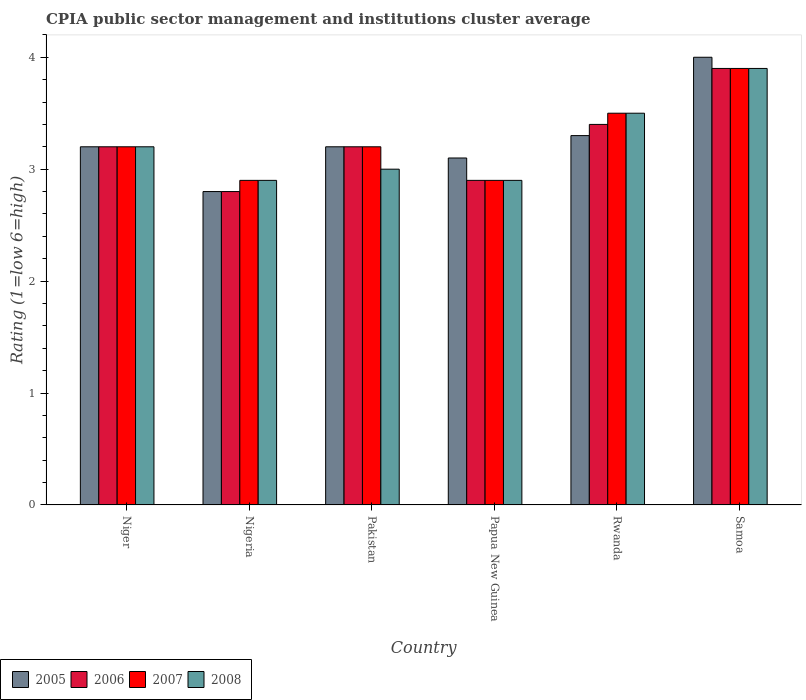How many different coloured bars are there?
Make the answer very short. 4. How many groups of bars are there?
Provide a short and direct response. 6. Are the number of bars per tick equal to the number of legend labels?
Offer a terse response. Yes. Are the number of bars on each tick of the X-axis equal?
Your answer should be very brief. Yes. How many bars are there on the 4th tick from the right?
Your answer should be compact. 4. What is the label of the 4th group of bars from the left?
Offer a terse response. Papua New Guinea. What is the CPIA rating in 2006 in Pakistan?
Make the answer very short. 3.2. In which country was the CPIA rating in 2006 maximum?
Provide a succinct answer. Samoa. In which country was the CPIA rating in 2008 minimum?
Keep it short and to the point. Nigeria. What is the total CPIA rating in 2005 in the graph?
Offer a terse response. 19.6. What is the difference between the CPIA rating in 2007 in Rwanda and the CPIA rating in 2005 in Niger?
Give a very brief answer. 0.3. What is the average CPIA rating in 2007 per country?
Provide a short and direct response. 3.27. What is the difference between the CPIA rating of/in 2006 and CPIA rating of/in 2008 in Rwanda?
Your response must be concise. -0.1. What is the ratio of the CPIA rating in 2007 in Nigeria to that in Samoa?
Make the answer very short. 0.74. Is the CPIA rating in 2006 in Niger less than that in Samoa?
Your answer should be compact. Yes. What is the difference between the highest and the second highest CPIA rating in 2007?
Your response must be concise. -0.4. What is the difference between the highest and the lowest CPIA rating in 2007?
Your answer should be very brief. 1. Is it the case that in every country, the sum of the CPIA rating in 2005 and CPIA rating in 2006 is greater than the sum of CPIA rating in 2008 and CPIA rating in 2007?
Your answer should be very brief. No. How many bars are there?
Ensure brevity in your answer.  24. How many countries are there in the graph?
Make the answer very short. 6. What is the difference between two consecutive major ticks on the Y-axis?
Your answer should be very brief. 1. Does the graph contain grids?
Your answer should be compact. No. Where does the legend appear in the graph?
Keep it short and to the point. Bottom left. What is the title of the graph?
Give a very brief answer. CPIA public sector management and institutions cluster average. Does "1989" appear as one of the legend labels in the graph?
Your response must be concise. No. What is the label or title of the X-axis?
Your answer should be very brief. Country. What is the label or title of the Y-axis?
Provide a short and direct response. Rating (1=low 6=high). What is the Rating (1=low 6=high) of 2005 in Niger?
Your answer should be very brief. 3.2. What is the Rating (1=low 6=high) in 2007 in Niger?
Make the answer very short. 3.2. What is the Rating (1=low 6=high) in 2008 in Niger?
Keep it short and to the point. 3.2. What is the Rating (1=low 6=high) of 2007 in Nigeria?
Your answer should be very brief. 2.9. What is the Rating (1=low 6=high) in 2005 in Pakistan?
Your response must be concise. 3.2. What is the Rating (1=low 6=high) of 2006 in Pakistan?
Make the answer very short. 3.2. What is the Rating (1=low 6=high) in 2007 in Pakistan?
Ensure brevity in your answer.  3.2. What is the Rating (1=low 6=high) of 2008 in Pakistan?
Your answer should be very brief. 3. What is the Rating (1=low 6=high) of 2005 in Papua New Guinea?
Provide a succinct answer. 3.1. What is the Rating (1=low 6=high) of 2006 in Papua New Guinea?
Your response must be concise. 2.9. What is the Rating (1=low 6=high) of 2007 in Papua New Guinea?
Give a very brief answer. 2.9. What is the Rating (1=low 6=high) in 2005 in Rwanda?
Make the answer very short. 3.3. What is the Rating (1=low 6=high) in 2008 in Rwanda?
Your response must be concise. 3.5. Across all countries, what is the maximum Rating (1=low 6=high) of 2006?
Make the answer very short. 3.9. Across all countries, what is the minimum Rating (1=low 6=high) of 2007?
Offer a terse response. 2.9. What is the total Rating (1=low 6=high) in 2005 in the graph?
Your answer should be very brief. 19.6. What is the total Rating (1=low 6=high) in 2007 in the graph?
Make the answer very short. 19.6. What is the total Rating (1=low 6=high) in 2008 in the graph?
Keep it short and to the point. 19.4. What is the difference between the Rating (1=low 6=high) of 2005 in Niger and that in Nigeria?
Provide a succinct answer. 0.4. What is the difference between the Rating (1=low 6=high) of 2007 in Niger and that in Nigeria?
Ensure brevity in your answer.  0.3. What is the difference between the Rating (1=low 6=high) in 2005 in Niger and that in Pakistan?
Provide a succinct answer. 0. What is the difference between the Rating (1=low 6=high) of 2007 in Niger and that in Pakistan?
Give a very brief answer. 0. What is the difference between the Rating (1=low 6=high) in 2006 in Niger and that in Papua New Guinea?
Make the answer very short. 0.3. What is the difference between the Rating (1=low 6=high) in 2007 in Niger and that in Papua New Guinea?
Offer a terse response. 0.3. What is the difference between the Rating (1=low 6=high) of 2008 in Niger and that in Papua New Guinea?
Ensure brevity in your answer.  0.3. What is the difference between the Rating (1=low 6=high) in 2008 in Niger and that in Rwanda?
Keep it short and to the point. -0.3. What is the difference between the Rating (1=low 6=high) of 2005 in Niger and that in Samoa?
Your answer should be compact. -0.8. What is the difference between the Rating (1=low 6=high) of 2008 in Niger and that in Samoa?
Offer a terse response. -0.7. What is the difference between the Rating (1=low 6=high) in 2005 in Nigeria and that in Pakistan?
Your response must be concise. -0.4. What is the difference between the Rating (1=low 6=high) of 2007 in Nigeria and that in Pakistan?
Keep it short and to the point. -0.3. What is the difference between the Rating (1=low 6=high) of 2005 in Nigeria and that in Papua New Guinea?
Ensure brevity in your answer.  -0.3. What is the difference between the Rating (1=low 6=high) in 2007 in Nigeria and that in Papua New Guinea?
Your answer should be compact. 0. What is the difference between the Rating (1=low 6=high) of 2005 in Nigeria and that in Samoa?
Provide a succinct answer. -1.2. What is the difference between the Rating (1=low 6=high) of 2006 in Nigeria and that in Samoa?
Give a very brief answer. -1.1. What is the difference between the Rating (1=low 6=high) in 2006 in Pakistan and that in Papua New Guinea?
Make the answer very short. 0.3. What is the difference between the Rating (1=low 6=high) of 2007 in Pakistan and that in Papua New Guinea?
Your response must be concise. 0.3. What is the difference between the Rating (1=low 6=high) in 2007 in Pakistan and that in Rwanda?
Keep it short and to the point. -0.3. What is the difference between the Rating (1=low 6=high) of 2005 in Pakistan and that in Samoa?
Make the answer very short. -0.8. What is the difference between the Rating (1=low 6=high) in 2006 in Pakistan and that in Samoa?
Provide a short and direct response. -0.7. What is the difference between the Rating (1=low 6=high) of 2007 in Pakistan and that in Samoa?
Provide a succinct answer. -0.7. What is the difference between the Rating (1=low 6=high) in 2008 in Pakistan and that in Samoa?
Provide a short and direct response. -0.9. What is the difference between the Rating (1=low 6=high) of 2005 in Papua New Guinea and that in Rwanda?
Your response must be concise. -0.2. What is the difference between the Rating (1=low 6=high) of 2006 in Papua New Guinea and that in Rwanda?
Your response must be concise. -0.5. What is the difference between the Rating (1=low 6=high) in 2007 in Papua New Guinea and that in Rwanda?
Provide a succinct answer. -0.6. What is the difference between the Rating (1=low 6=high) in 2008 in Papua New Guinea and that in Rwanda?
Keep it short and to the point. -0.6. What is the difference between the Rating (1=low 6=high) of 2005 in Papua New Guinea and that in Samoa?
Offer a very short reply. -0.9. What is the difference between the Rating (1=low 6=high) of 2006 in Papua New Guinea and that in Samoa?
Offer a terse response. -1. What is the difference between the Rating (1=low 6=high) of 2008 in Papua New Guinea and that in Samoa?
Provide a succinct answer. -1. What is the difference between the Rating (1=low 6=high) in 2005 in Rwanda and that in Samoa?
Ensure brevity in your answer.  -0.7. What is the difference between the Rating (1=low 6=high) in 2006 in Rwanda and that in Samoa?
Offer a very short reply. -0.5. What is the difference between the Rating (1=low 6=high) in 2008 in Rwanda and that in Samoa?
Give a very brief answer. -0.4. What is the difference between the Rating (1=low 6=high) in 2005 in Niger and the Rating (1=low 6=high) in 2006 in Nigeria?
Offer a terse response. 0.4. What is the difference between the Rating (1=low 6=high) of 2006 in Niger and the Rating (1=low 6=high) of 2007 in Nigeria?
Ensure brevity in your answer.  0.3. What is the difference between the Rating (1=low 6=high) of 2007 in Niger and the Rating (1=low 6=high) of 2008 in Nigeria?
Offer a terse response. 0.3. What is the difference between the Rating (1=low 6=high) in 2005 in Niger and the Rating (1=low 6=high) in 2007 in Pakistan?
Your answer should be compact. 0. What is the difference between the Rating (1=low 6=high) of 2005 in Niger and the Rating (1=low 6=high) of 2008 in Pakistan?
Offer a very short reply. 0.2. What is the difference between the Rating (1=low 6=high) of 2006 in Niger and the Rating (1=low 6=high) of 2008 in Pakistan?
Ensure brevity in your answer.  0.2. What is the difference between the Rating (1=low 6=high) of 2006 in Niger and the Rating (1=low 6=high) of 2007 in Papua New Guinea?
Your response must be concise. 0.3. What is the difference between the Rating (1=low 6=high) in 2006 in Niger and the Rating (1=low 6=high) in 2008 in Papua New Guinea?
Give a very brief answer. 0.3. What is the difference between the Rating (1=low 6=high) in 2005 in Niger and the Rating (1=low 6=high) in 2007 in Rwanda?
Your answer should be compact. -0.3. What is the difference between the Rating (1=low 6=high) in 2007 in Niger and the Rating (1=low 6=high) in 2008 in Rwanda?
Your response must be concise. -0.3. What is the difference between the Rating (1=low 6=high) of 2005 in Niger and the Rating (1=low 6=high) of 2006 in Samoa?
Offer a very short reply. -0.7. What is the difference between the Rating (1=low 6=high) of 2005 in Niger and the Rating (1=low 6=high) of 2008 in Samoa?
Your answer should be very brief. -0.7. What is the difference between the Rating (1=low 6=high) in 2005 in Nigeria and the Rating (1=low 6=high) in 2008 in Pakistan?
Your answer should be compact. -0.2. What is the difference between the Rating (1=low 6=high) in 2006 in Nigeria and the Rating (1=low 6=high) in 2007 in Pakistan?
Your answer should be very brief. -0.4. What is the difference between the Rating (1=low 6=high) in 2006 in Nigeria and the Rating (1=low 6=high) in 2008 in Pakistan?
Offer a terse response. -0.2. What is the difference between the Rating (1=low 6=high) in 2007 in Nigeria and the Rating (1=low 6=high) in 2008 in Pakistan?
Provide a short and direct response. -0.1. What is the difference between the Rating (1=low 6=high) in 2006 in Nigeria and the Rating (1=low 6=high) in 2007 in Papua New Guinea?
Keep it short and to the point. -0.1. What is the difference between the Rating (1=low 6=high) of 2006 in Nigeria and the Rating (1=low 6=high) of 2008 in Papua New Guinea?
Provide a short and direct response. -0.1. What is the difference between the Rating (1=low 6=high) of 2007 in Nigeria and the Rating (1=low 6=high) of 2008 in Papua New Guinea?
Your response must be concise. 0. What is the difference between the Rating (1=low 6=high) in 2005 in Nigeria and the Rating (1=low 6=high) in 2006 in Rwanda?
Make the answer very short. -0.6. What is the difference between the Rating (1=low 6=high) in 2005 in Nigeria and the Rating (1=low 6=high) in 2007 in Rwanda?
Provide a succinct answer. -0.7. What is the difference between the Rating (1=low 6=high) of 2005 in Nigeria and the Rating (1=low 6=high) of 2008 in Rwanda?
Provide a short and direct response. -0.7. What is the difference between the Rating (1=low 6=high) of 2006 in Nigeria and the Rating (1=low 6=high) of 2008 in Rwanda?
Offer a very short reply. -0.7. What is the difference between the Rating (1=low 6=high) of 2007 in Nigeria and the Rating (1=low 6=high) of 2008 in Rwanda?
Provide a succinct answer. -0.6. What is the difference between the Rating (1=low 6=high) of 2005 in Nigeria and the Rating (1=low 6=high) of 2006 in Samoa?
Provide a short and direct response. -1.1. What is the difference between the Rating (1=low 6=high) of 2007 in Nigeria and the Rating (1=low 6=high) of 2008 in Samoa?
Offer a very short reply. -1. What is the difference between the Rating (1=low 6=high) of 2005 in Pakistan and the Rating (1=low 6=high) of 2007 in Papua New Guinea?
Offer a terse response. 0.3. What is the difference between the Rating (1=low 6=high) in 2005 in Pakistan and the Rating (1=low 6=high) in 2008 in Papua New Guinea?
Make the answer very short. 0.3. What is the difference between the Rating (1=low 6=high) in 2006 in Pakistan and the Rating (1=low 6=high) in 2007 in Papua New Guinea?
Give a very brief answer. 0.3. What is the difference between the Rating (1=low 6=high) in 2006 in Pakistan and the Rating (1=low 6=high) in 2008 in Papua New Guinea?
Keep it short and to the point. 0.3. What is the difference between the Rating (1=low 6=high) in 2007 in Pakistan and the Rating (1=low 6=high) in 2008 in Papua New Guinea?
Provide a short and direct response. 0.3. What is the difference between the Rating (1=low 6=high) of 2005 in Pakistan and the Rating (1=low 6=high) of 2007 in Rwanda?
Your answer should be compact. -0.3. What is the difference between the Rating (1=low 6=high) in 2005 in Pakistan and the Rating (1=low 6=high) in 2008 in Rwanda?
Ensure brevity in your answer.  -0.3. What is the difference between the Rating (1=low 6=high) in 2005 in Pakistan and the Rating (1=low 6=high) in 2007 in Samoa?
Your answer should be very brief. -0.7. What is the difference between the Rating (1=low 6=high) in 2005 in Pakistan and the Rating (1=low 6=high) in 2008 in Samoa?
Provide a short and direct response. -0.7. What is the difference between the Rating (1=low 6=high) in 2006 in Pakistan and the Rating (1=low 6=high) in 2008 in Samoa?
Your response must be concise. -0.7. What is the difference between the Rating (1=low 6=high) of 2005 in Papua New Guinea and the Rating (1=low 6=high) of 2007 in Rwanda?
Offer a terse response. -0.4. What is the difference between the Rating (1=low 6=high) of 2007 in Papua New Guinea and the Rating (1=low 6=high) of 2008 in Rwanda?
Provide a succinct answer. -0.6. What is the difference between the Rating (1=low 6=high) in 2005 in Papua New Guinea and the Rating (1=low 6=high) in 2008 in Samoa?
Provide a short and direct response. -0.8. What is the difference between the Rating (1=low 6=high) of 2007 in Papua New Guinea and the Rating (1=low 6=high) of 2008 in Samoa?
Keep it short and to the point. -1. What is the difference between the Rating (1=low 6=high) in 2005 in Rwanda and the Rating (1=low 6=high) in 2008 in Samoa?
Give a very brief answer. -0.6. What is the difference between the Rating (1=low 6=high) of 2006 in Rwanda and the Rating (1=low 6=high) of 2008 in Samoa?
Your answer should be compact. -0.5. What is the average Rating (1=low 6=high) of 2005 per country?
Keep it short and to the point. 3.27. What is the average Rating (1=low 6=high) of 2006 per country?
Your response must be concise. 3.23. What is the average Rating (1=low 6=high) in 2007 per country?
Give a very brief answer. 3.27. What is the average Rating (1=low 6=high) of 2008 per country?
Provide a succinct answer. 3.23. What is the difference between the Rating (1=low 6=high) in 2006 and Rating (1=low 6=high) in 2007 in Niger?
Ensure brevity in your answer.  0. What is the difference between the Rating (1=low 6=high) of 2005 and Rating (1=low 6=high) of 2006 in Nigeria?
Offer a very short reply. 0. What is the difference between the Rating (1=low 6=high) of 2005 and Rating (1=low 6=high) of 2007 in Nigeria?
Make the answer very short. -0.1. What is the difference between the Rating (1=low 6=high) of 2005 and Rating (1=low 6=high) of 2008 in Nigeria?
Your response must be concise. -0.1. What is the difference between the Rating (1=low 6=high) of 2005 and Rating (1=low 6=high) of 2006 in Pakistan?
Your answer should be compact. 0. What is the difference between the Rating (1=low 6=high) in 2005 and Rating (1=low 6=high) in 2007 in Pakistan?
Provide a short and direct response. 0. What is the difference between the Rating (1=low 6=high) of 2005 and Rating (1=low 6=high) of 2008 in Pakistan?
Your answer should be very brief. 0.2. What is the difference between the Rating (1=low 6=high) of 2006 and Rating (1=low 6=high) of 2008 in Pakistan?
Your answer should be compact. 0.2. What is the difference between the Rating (1=low 6=high) of 2007 and Rating (1=low 6=high) of 2008 in Pakistan?
Offer a terse response. 0.2. What is the difference between the Rating (1=low 6=high) in 2007 and Rating (1=low 6=high) in 2008 in Papua New Guinea?
Provide a short and direct response. 0. What is the difference between the Rating (1=low 6=high) of 2005 and Rating (1=low 6=high) of 2006 in Rwanda?
Keep it short and to the point. -0.1. What is the difference between the Rating (1=low 6=high) in 2005 and Rating (1=low 6=high) in 2007 in Rwanda?
Offer a very short reply. -0.2. What is the difference between the Rating (1=low 6=high) of 2007 and Rating (1=low 6=high) of 2008 in Rwanda?
Ensure brevity in your answer.  0. What is the difference between the Rating (1=low 6=high) of 2005 and Rating (1=low 6=high) of 2007 in Samoa?
Offer a very short reply. 0.1. What is the difference between the Rating (1=low 6=high) in 2005 and Rating (1=low 6=high) in 2008 in Samoa?
Provide a short and direct response. 0.1. What is the difference between the Rating (1=low 6=high) of 2006 and Rating (1=low 6=high) of 2008 in Samoa?
Provide a succinct answer. 0. What is the ratio of the Rating (1=low 6=high) of 2005 in Niger to that in Nigeria?
Provide a succinct answer. 1.14. What is the ratio of the Rating (1=low 6=high) of 2006 in Niger to that in Nigeria?
Offer a very short reply. 1.14. What is the ratio of the Rating (1=low 6=high) in 2007 in Niger to that in Nigeria?
Offer a very short reply. 1.1. What is the ratio of the Rating (1=low 6=high) in 2008 in Niger to that in Nigeria?
Offer a very short reply. 1.1. What is the ratio of the Rating (1=low 6=high) of 2007 in Niger to that in Pakistan?
Your answer should be very brief. 1. What is the ratio of the Rating (1=low 6=high) of 2008 in Niger to that in Pakistan?
Provide a succinct answer. 1.07. What is the ratio of the Rating (1=low 6=high) of 2005 in Niger to that in Papua New Guinea?
Provide a short and direct response. 1.03. What is the ratio of the Rating (1=low 6=high) in 2006 in Niger to that in Papua New Guinea?
Your answer should be compact. 1.1. What is the ratio of the Rating (1=low 6=high) of 2007 in Niger to that in Papua New Guinea?
Offer a terse response. 1.1. What is the ratio of the Rating (1=low 6=high) of 2008 in Niger to that in Papua New Guinea?
Your answer should be very brief. 1.1. What is the ratio of the Rating (1=low 6=high) in 2005 in Niger to that in Rwanda?
Your answer should be very brief. 0.97. What is the ratio of the Rating (1=low 6=high) of 2006 in Niger to that in Rwanda?
Your response must be concise. 0.94. What is the ratio of the Rating (1=low 6=high) in 2007 in Niger to that in Rwanda?
Ensure brevity in your answer.  0.91. What is the ratio of the Rating (1=low 6=high) of 2008 in Niger to that in Rwanda?
Give a very brief answer. 0.91. What is the ratio of the Rating (1=low 6=high) in 2006 in Niger to that in Samoa?
Your response must be concise. 0.82. What is the ratio of the Rating (1=low 6=high) in 2007 in Niger to that in Samoa?
Your answer should be very brief. 0.82. What is the ratio of the Rating (1=low 6=high) of 2008 in Niger to that in Samoa?
Provide a succinct answer. 0.82. What is the ratio of the Rating (1=low 6=high) of 2005 in Nigeria to that in Pakistan?
Provide a short and direct response. 0.88. What is the ratio of the Rating (1=low 6=high) of 2007 in Nigeria to that in Pakistan?
Give a very brief answer. 0.91. What is the ratio of the Rating (1=low 6=high) in 2008 in Nigeria to that in Pakistan?
Give a very brief answer. 0.97. What is the ratio of the Rating (1=low 6=high) of 2005 in Nigeria to that in Papua New Guinea?
Offer a terse response. 0.9. What is the ratio of the Rating (1=low 6=high) in 2006 in Nigeria to that in Papua New Guinea?
Provide a short and direct response. 0.97. What is the ratio of the Rating (1=low 6=high) in 2007 in Nigeria to that in Papua New Guinea?
Offer a very short reply. 1. What is the ratio of the Rating (1=low 6=high) of 2008 in Nigeria to that in Papua New Guinea?
Make the answer very short. 1. What is the ratio of the Rating (1=low 6=high) in 2005 in Nigeria to that in Rwanda?
Your response must be concise. 0.85. What is the ratio of the Rating (1=low 6=high) in 2006 in Nigeria to that in Rwanda?
Keep it short and to the point. 0.82. What is the ratio of the Rating (1=low 6=high) of 2007 in Nigeria to that in Rwanda?
Provide a short and direct response. 0.83. What is the ratio of the Rating (1=low 6=high) of 2008 in Nigeria to that in Rwanda?
Offer a very short reply. 0.83. What is the ratio of the Rating (1=low 6=high) of 2006 in Nigeria to that in Samoa?
Offer a very short reply. 0.72. What is the ratio of the Rating (1=low 6=high) in 2007 in Nigeria to that in Samoa?
Make the answer very short. 0.74. What is the ratio of the Rating (1=low 6=high) in 2008 in Nigeria to that in Samoa?
Offer a very short reply. 0.74. What is the ratio of the Rating (1=low 6=high) of 2005 in Pakistan to that in Papua New Guinea?
Ensure brevity in your answer.  1.03. What is the ratio of the Rating (1=low 6=high) of 2006 in Pakistan to that in Papua New Guinea?
Your answer should be very brief. 1.1. What is the ratio of the Rating (1=low 6=high) of 2007 in Pakistan to that in Papua New Guinea?
Offer a terse response. 1.1. What is the ratio of the Rating (1=low 6=high) of 2008 in Pakistan to that in Papua New Guinea?
Your response must be concise. 1.03. What is the ratio of the Rating (1=low 6=high) of 2005 in Pakistan to that in Rwanda?
Provide a succinct answer. 0.97. What is the ratio of the Rating (1=low 6=high) of 2007 in Pakistan to that in Rwanda?
Ensure brevity in your answer.  0.91. What is the ratio of the Rating (1=low 6=high) of 2008 in Pakistan to that in Rwanda?
Ensure brevity in your answer.  0.86. What is the ratio of the Rating (1=low 6=high) of 2005 in Pakistan to that in Samoa?
Offer a terse response. 0.8. What is the ratio of the Rating (1=low 6=high) in 2006 in Pakistan to that in Samoa?
Keep it short and to the point. 0.82. What is the ratio of the Rating (1=low 6=high) of 2007 in Pakistan to that in Samoa?
Your answer should be very brief. 0.82. What is the ratio of the Rating (1=low 6=high) of 2008 in Pakistan to that in Samoa?
Ensure brevity in your answer.  0.77. What is the ratio of the Rating (1=low 6=high) of 2005 in Papua New Guinea to that in Rwanda?
Keep it short and to the point. 0.94. What is the ratio of the Rating (1=low 6=high) of 2006 in Papua New Guinea to that in Rwanda?
Ensure brevity in your answer.  0.85. What is the ratio of the Rating (1=low 6=high) in 2007 in Papua New Guinea to that in Rwanda?
Your response must be concise. 0.83. What is the ratio of the Rating (1=low 6=high) of 2008 in Papua New Guinea to that in Rwanda?
Your answer should be very brief. 0.83. What is the ratio of the Rating (1=low 6=high) in 2005 in Papua New Guinea to that in Samoa?
Offer a terse response. 0.78. What is the ratio of the Rating (1=low 6=high) of 2006 in Papua New Guinea to that in Samoa?
Your answer should be very brief. 0.74. What is the ratio of the Rating (1=low 6=high) in 2007 in Papua New Guinea to that in Samoa?
Make the answer very short. 0.74. What is the ratio of the Rating (1=low 6=high) in 2008 in Papua New Guinea to that in Samoa?
Your answer should be very brief. 0.74. What is the ratio of the Rating (1=low 6=high) in 2005 in Rwanda to that in Samoa?
Offer a very short reply. 0.82. What is the ratio of the Rating (1=low 6=high) in 2006 in Rwanda to that in Samoa?
Give a very brief answer. 0.87. What is the ratio of the Rating (1=low 6=high) of 2007 in Rwanda to that in Samoa?
Give a very brief answer. 0.9. What is the ratio of the Rating (1=low 6=high) in 2008 in Rwanda to that in Samoa?
Make the answer very short. 0.9. What is the difference between the highest and the second highest Rating (1=low 6=high) of 2008?
Your answer should be very brief. 0.4. What is the difference between the highest and the lowest Rating (1=low 6=high) in 2005?
Ensure brevity in your answer.  1.2. What is the difference between the highest and the lowest Rating (1=low 6=high) in 2007?
Your answer should be very brief. 1. What is the difference between the highest and the lowest Rating (1=low 6=high) of 2008?
Offer a very short reply. 1. 